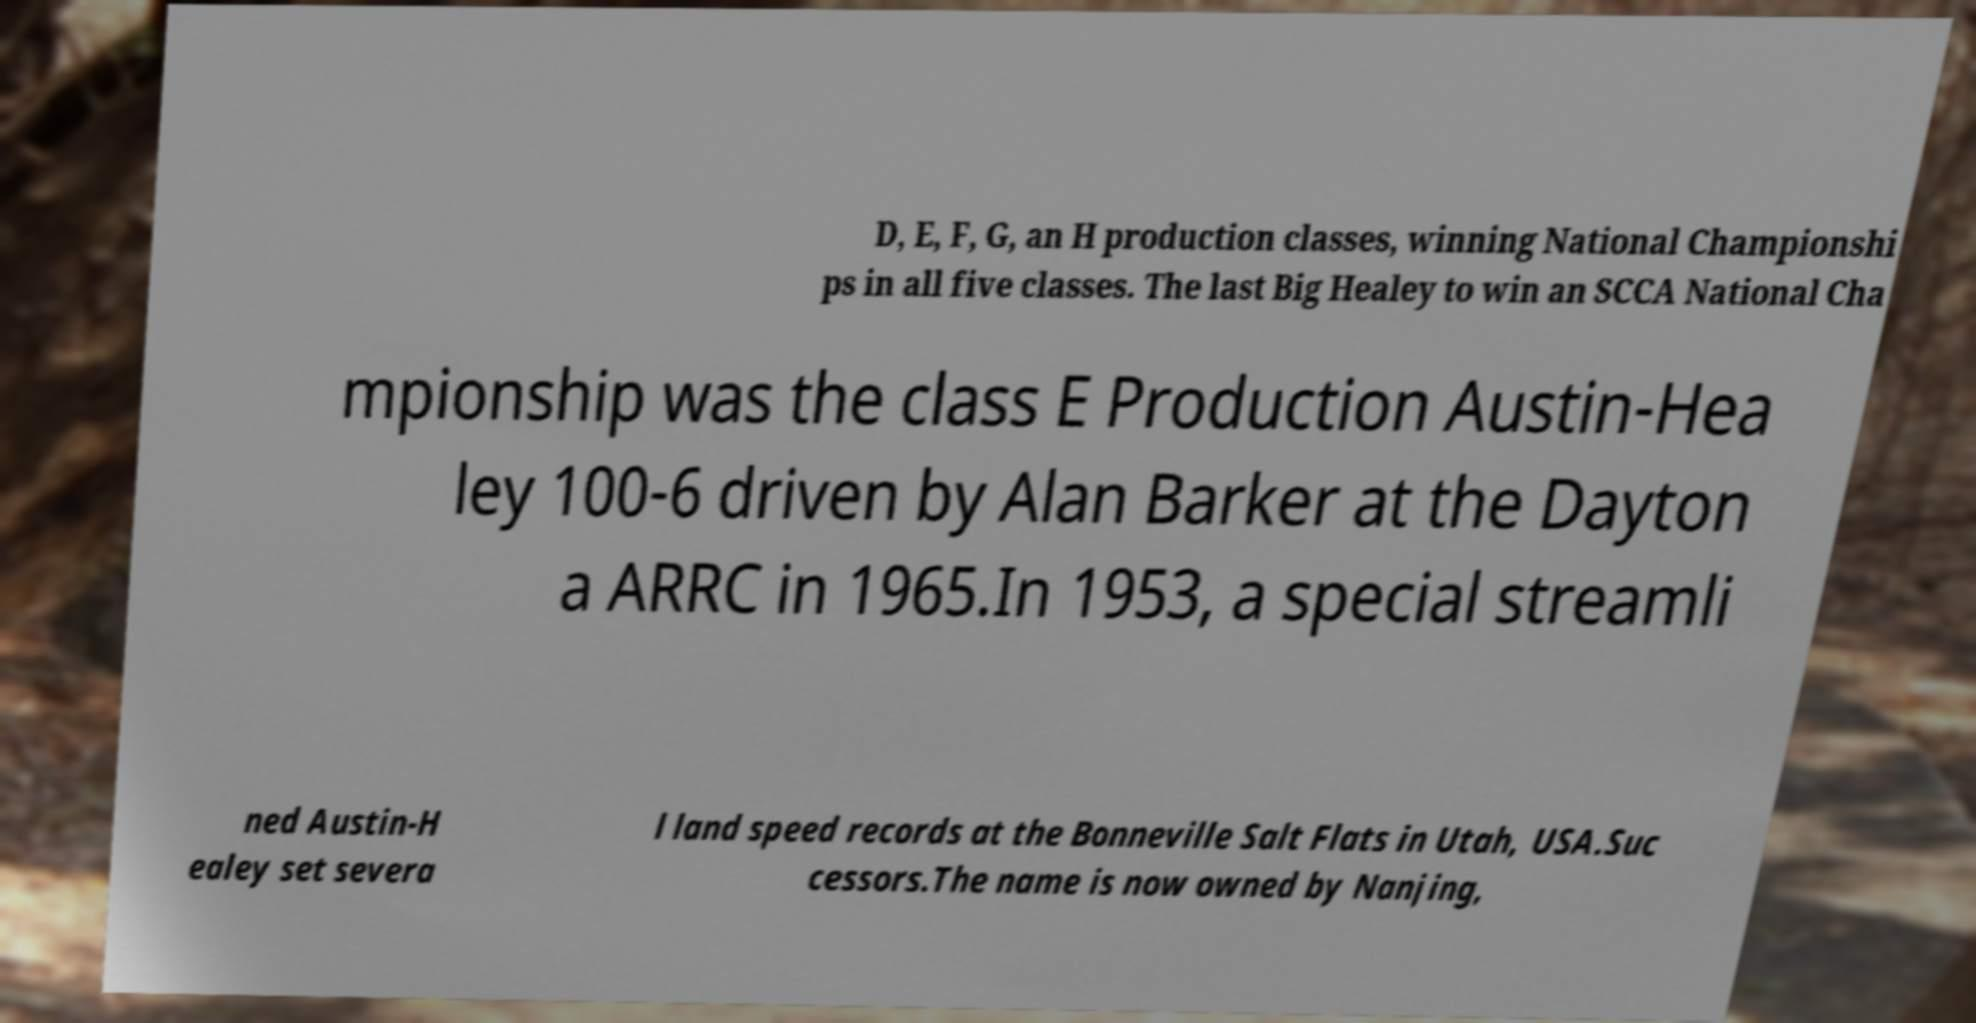Can you read and provide the text displayed in the image?This photo seems to have some interesting text. Can you extract and type it out for me? D, E, F, G, an H production classes, winning National Championshi ps in all five classes. The last Big Healey to win an SCCA National Cha mpionship was the class E Production Austin-Hea ley 100-6 driven by Alan Barker at the Dayton a ARRC in 1965.In 1953, a special streamli ned Austin-H ealey set severa l land speed records at the Bonneville Salt Flats in Utah, USA.Suc cessors.The name is now owned by Nanjing, 